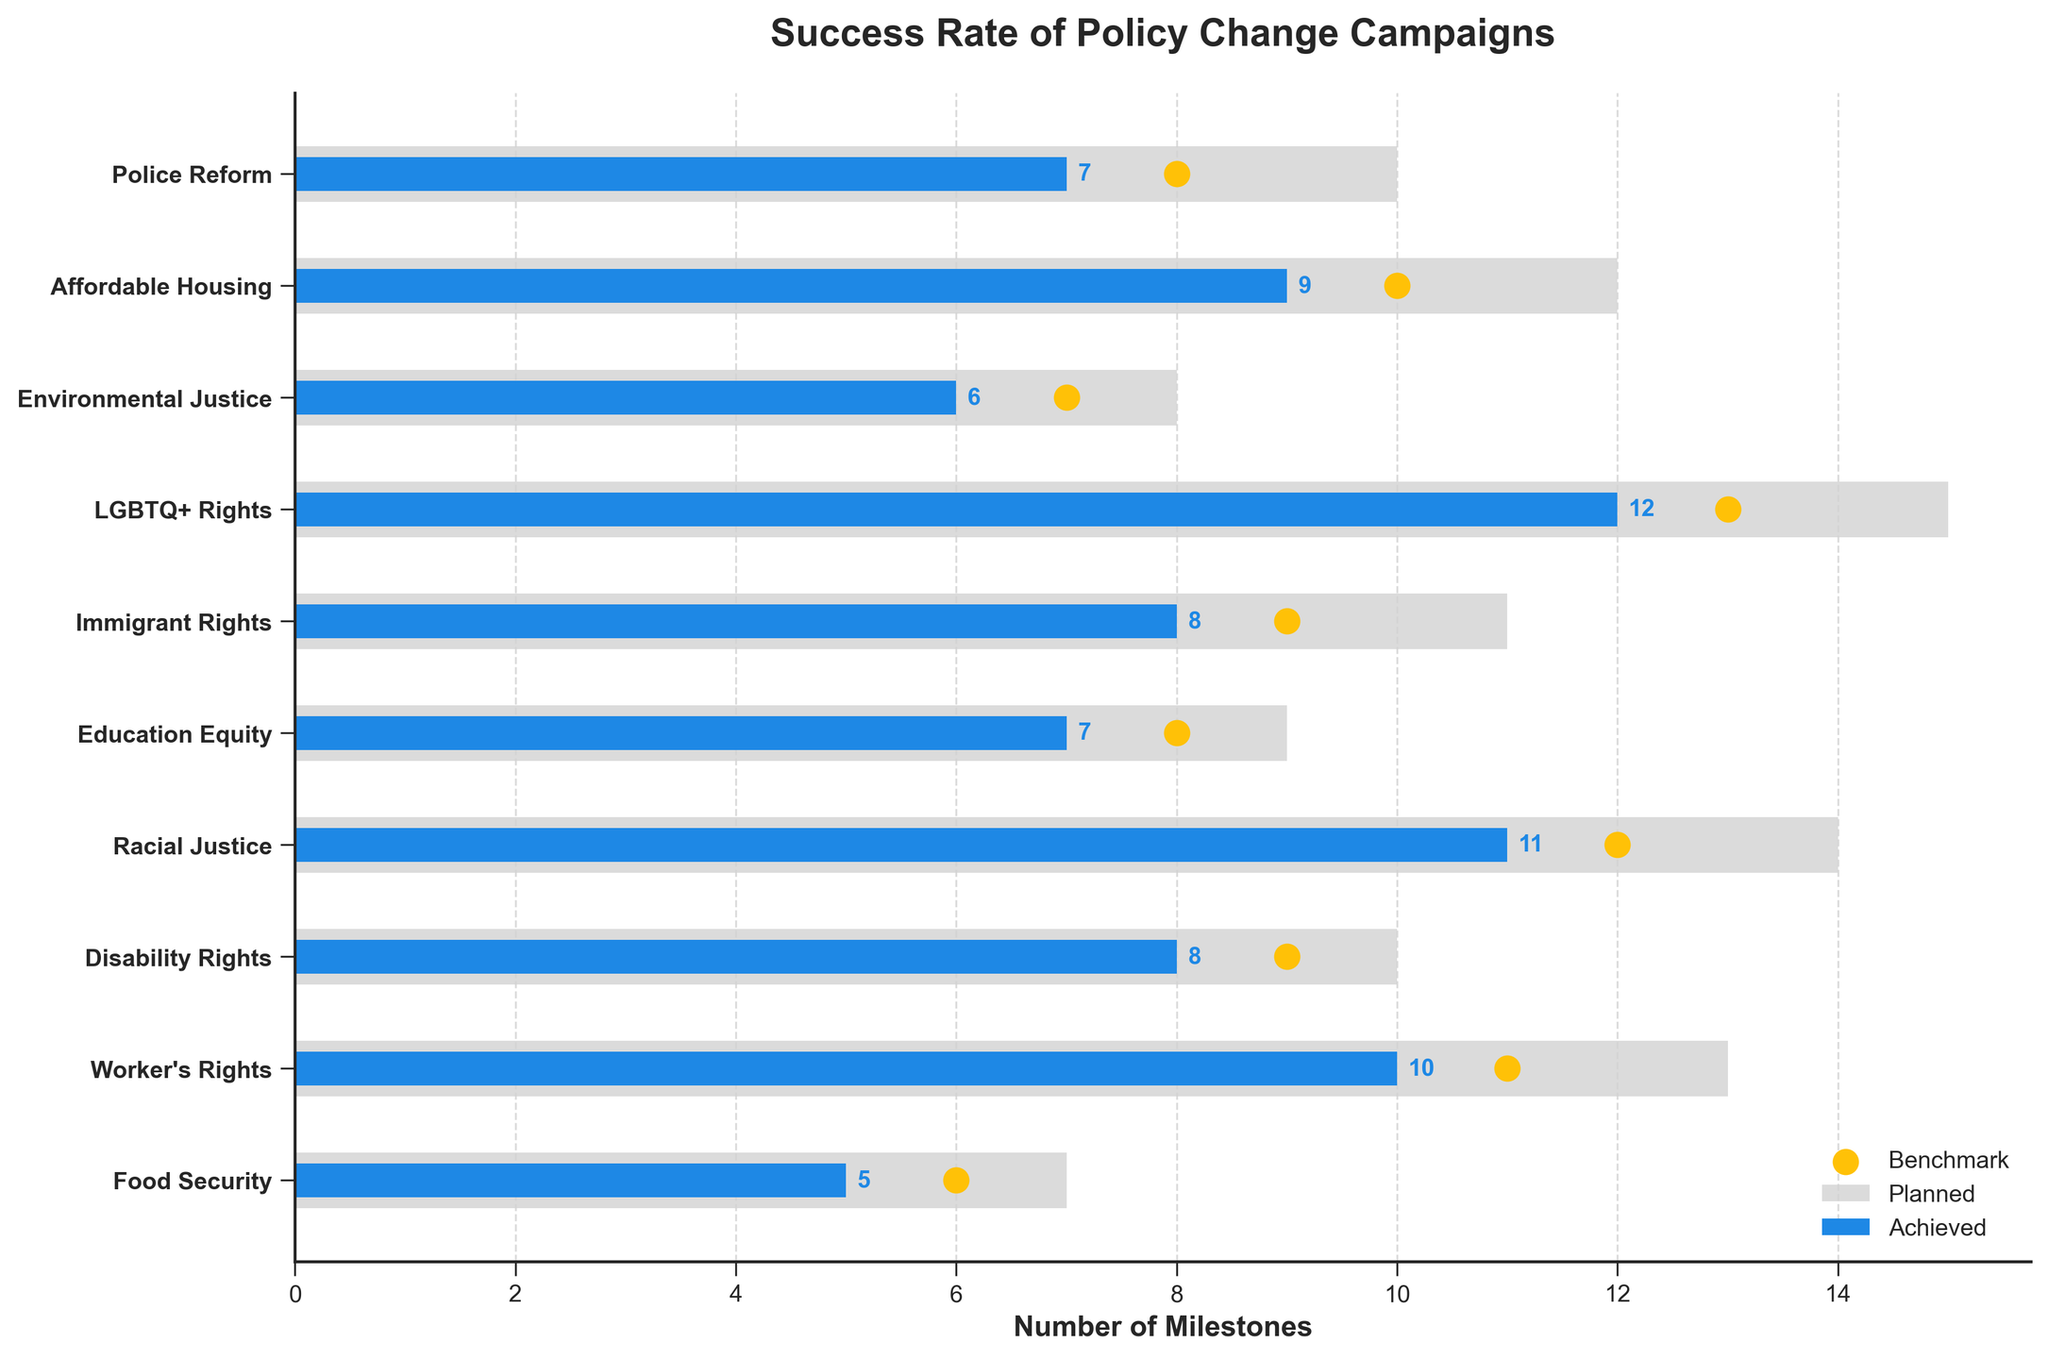what is the title of the chart? The title of the chart is usually located at the top and gives a brief description of what the chart is about. Here, it is clearly stated at the top of the figure indicating that the chart is about "Success Rate of Policy Change Campaigns".
Answer: Success Rate of Policy Change Campaigns Which campaign has the highest number of planned milestones? To determine this, one should look at the bar lengths in light gray color representing the planned milestones for each campaign. The longest bar corresponds to the LGBTQ+ Rights campaign.
Answer: LGBTQ+ Rights How many campaigns have achieved more milestones than the benchmark? We have to compare the blue bars (achieved milestones) to the yellow dots (benchmark). We see that no campaign's blue bar extends beyond its corresponding yellow dot. Therefore, no campaign has achieved more milestones than the benchmark.
Answer: 0 How many more milestones did the "LGBTQ+ Rights" campaign achieve compared to "Food Security"? First, locate the "LGBTQ+ Rights" and "Food Security" campaigns in the chart. "LGBTQ+ Rights" achieved 12 milestones and "Food Security" achieved 5 milestones. Subtract 5 from 12.
Answer: 7 Which campaign failed to achieve its benchmark by the widest margin? To find this, compare the distance between the blue bar (achieved milestones) and the yellow dot (benchmark) for each campaign. The "Education Equity" campaign has a significant gap between achieved (7 milestones) and benchmark (8 milestones) but not the widest. The widest gap is for "Racial Justice" which achieved 11 milestones but the benchmark is 12, a gap of 1 milestone.
Answer: Racial Justice Which campaign performed closest to its benchmark? To determine this, analyze the difference between the blue bar (achieved milestones) and the yellow dot (benchmark) for each campaign. The "Environmental Justice" campaign achieved 6 milestones with a benchmark of 7, which seems closely aligned.
Answer: Environmental Justice What is the sum of all planned milestones? Add up all the planned milestones numbers: 10 + 12 + 8 + 15 + 11 + 9 + 14 + 10 + 13 + 7. Performing the addition gives 109.
Answer: 109 By how much did the "Worker's Rights" campaign fall short of its planned milestones? For the "Worker's Rights" campaign, the planned milestones are 13 and the achieved milestones are 10. Subtract the achieved milestones from the planned milestones to find how many were missed: 13 - 10 = 3.
Answer: 3 Which campaign has achieved exactly 8 milestones? Look for the blue bars corresponding to the "Achieved Milestones" and identify which one corresponds to the milestone value of 8. Both "Disability Rights" and "Immigrant Rights" have achieved 8 milestones.
Answer: Disability Rights, Immigrant Rights 